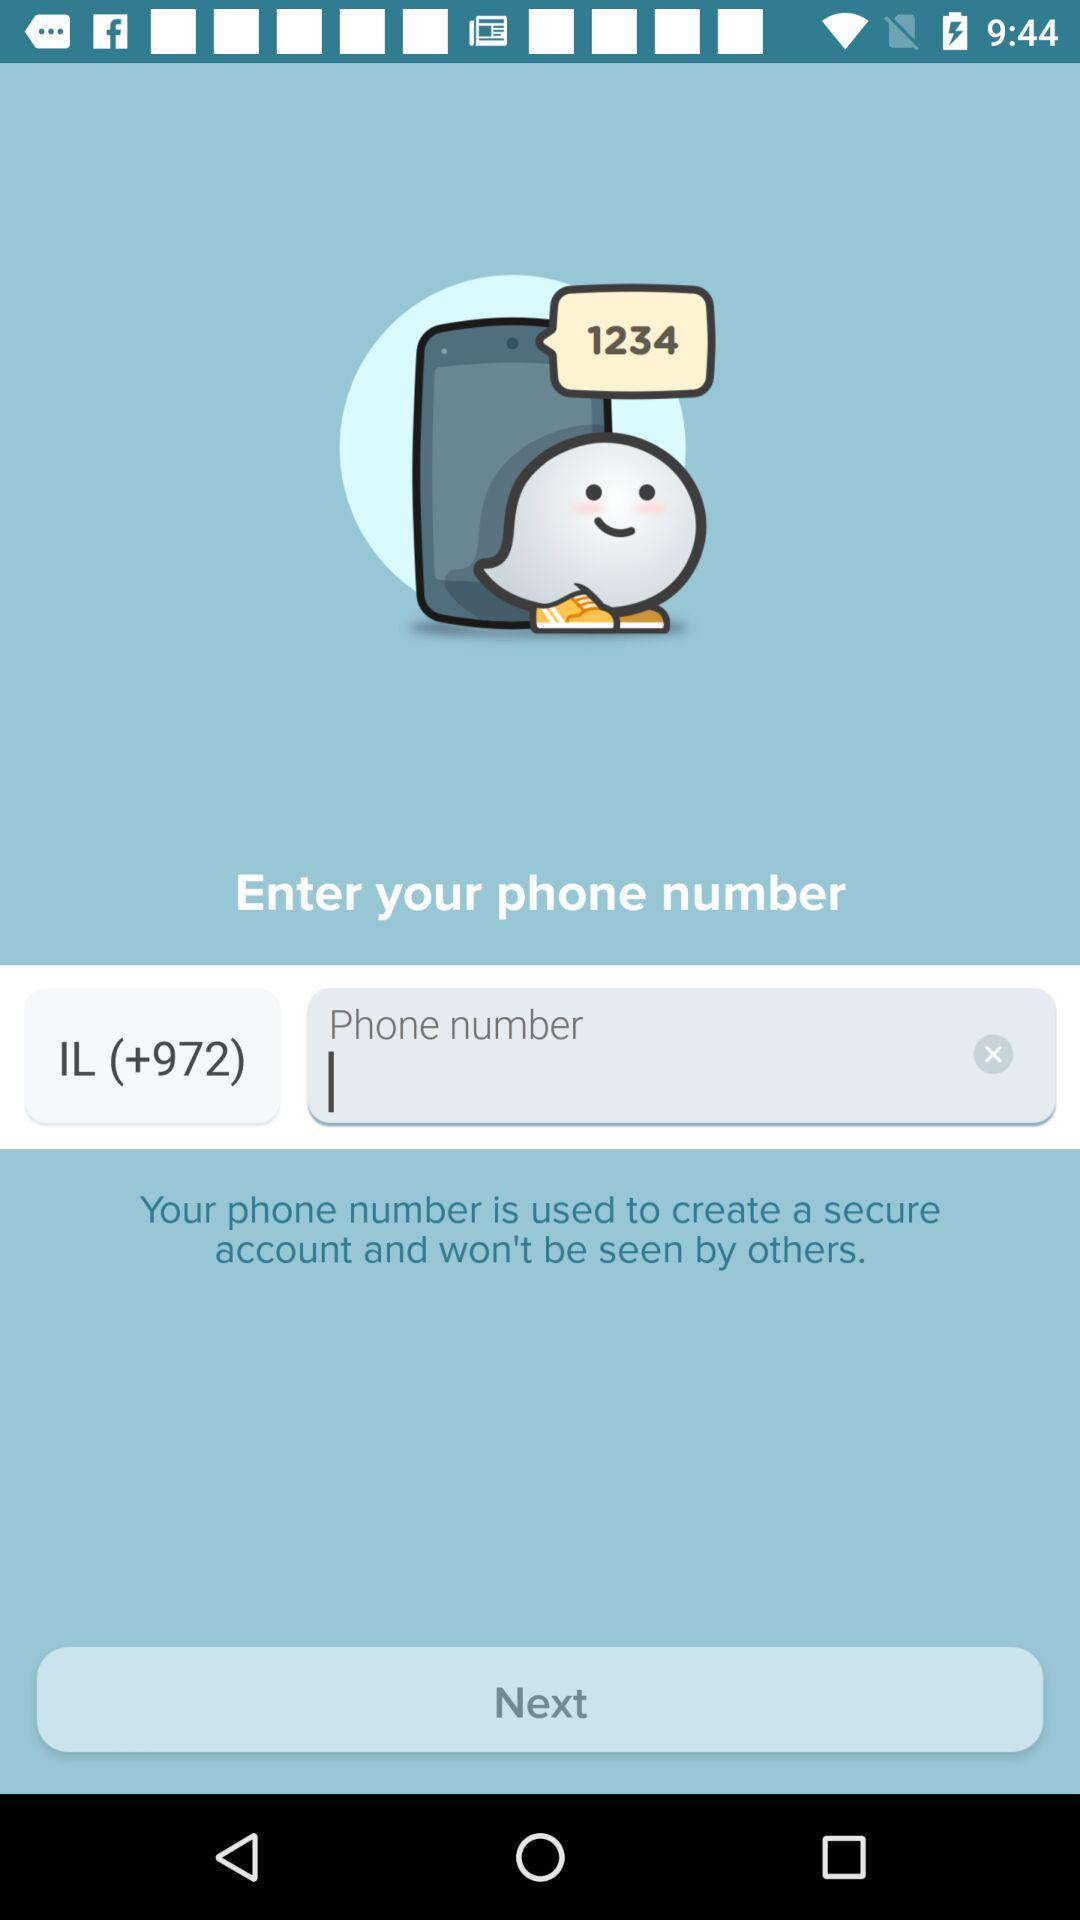What country code is used? The country code is (+972). 